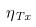<formula> <loc_0><loc_0><loc_500><loc_500>\eta _ { T x }</formula> 